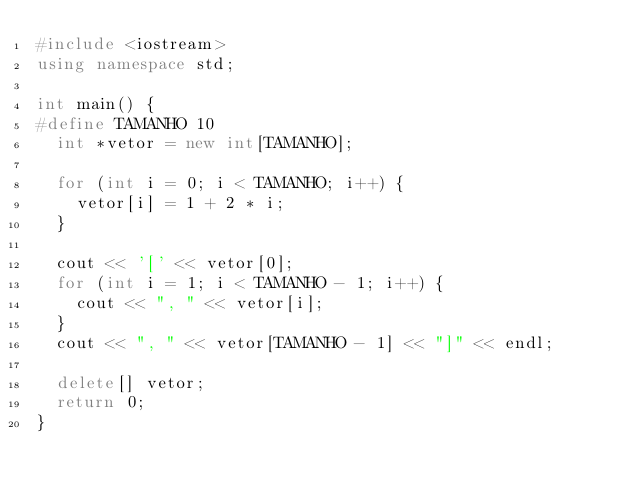<code> <loc_0><loc_0><loc_500><loc_500><_C++_>#include <iostream>
using namespace std;

int main() {
#define TAMANHO 10
  int *vetor = new int[TAMANHO];

  for (int i = 0; i < TAMANHO; i++) {
    vetor[i] = 1 + 2 * i;
  }

  cout << '[' << vetor[0];
  for (int i = 1; i < TAMANHO - 1; i++) {
    cout << ", " << vetor[i];
  }
  cout << ", " << vetor[TAMANHO - 1] << "]" << endl;

  delete[] vetor;
  return 0;
}</code> 